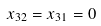Convert formula to latex. <formula><loc_0><loc_0><loc_500><loc_500>x _ { 3 2 } = x _ { 3 1 } = 0</formula> 